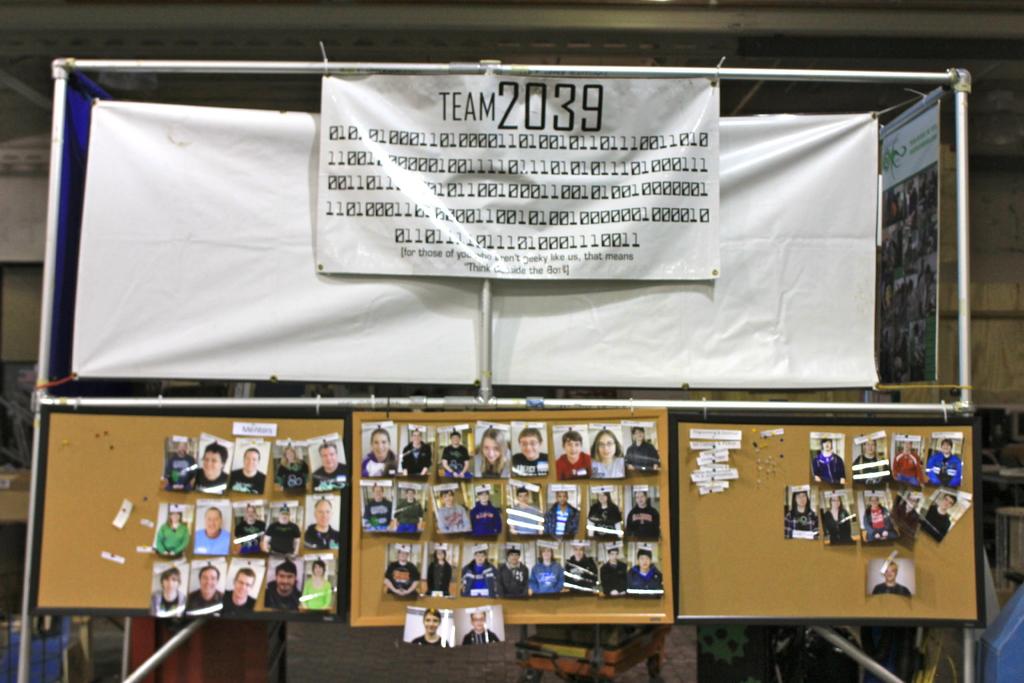What word is written to the left of 2039, at the top of the sign?
Your response must be concise. Team. The image is team 2039?
Make the answer very short. Yes. 